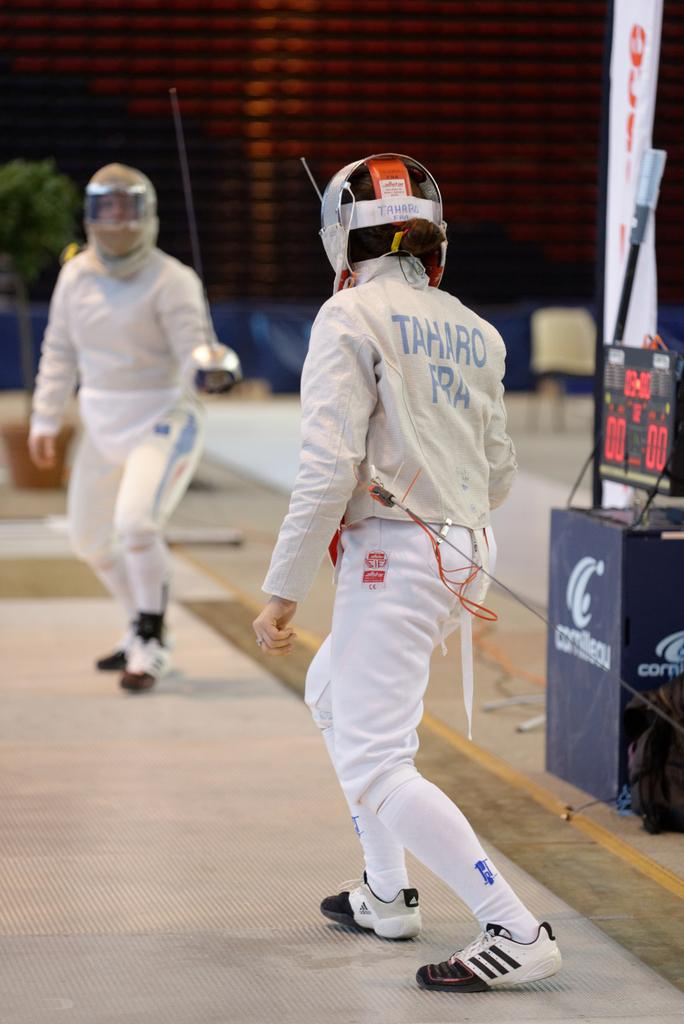Who or what is present in the image? There are people in the image. What are the people holding in the image? The people are holding swords. What are the people wearing in the image? The people are wearing helmets. What can be seen in the background of the image? There are plants and a hoarding in the background of the image. How does the rod help the people in the image? There is no rod present in the image; the people are holding swords instead. 